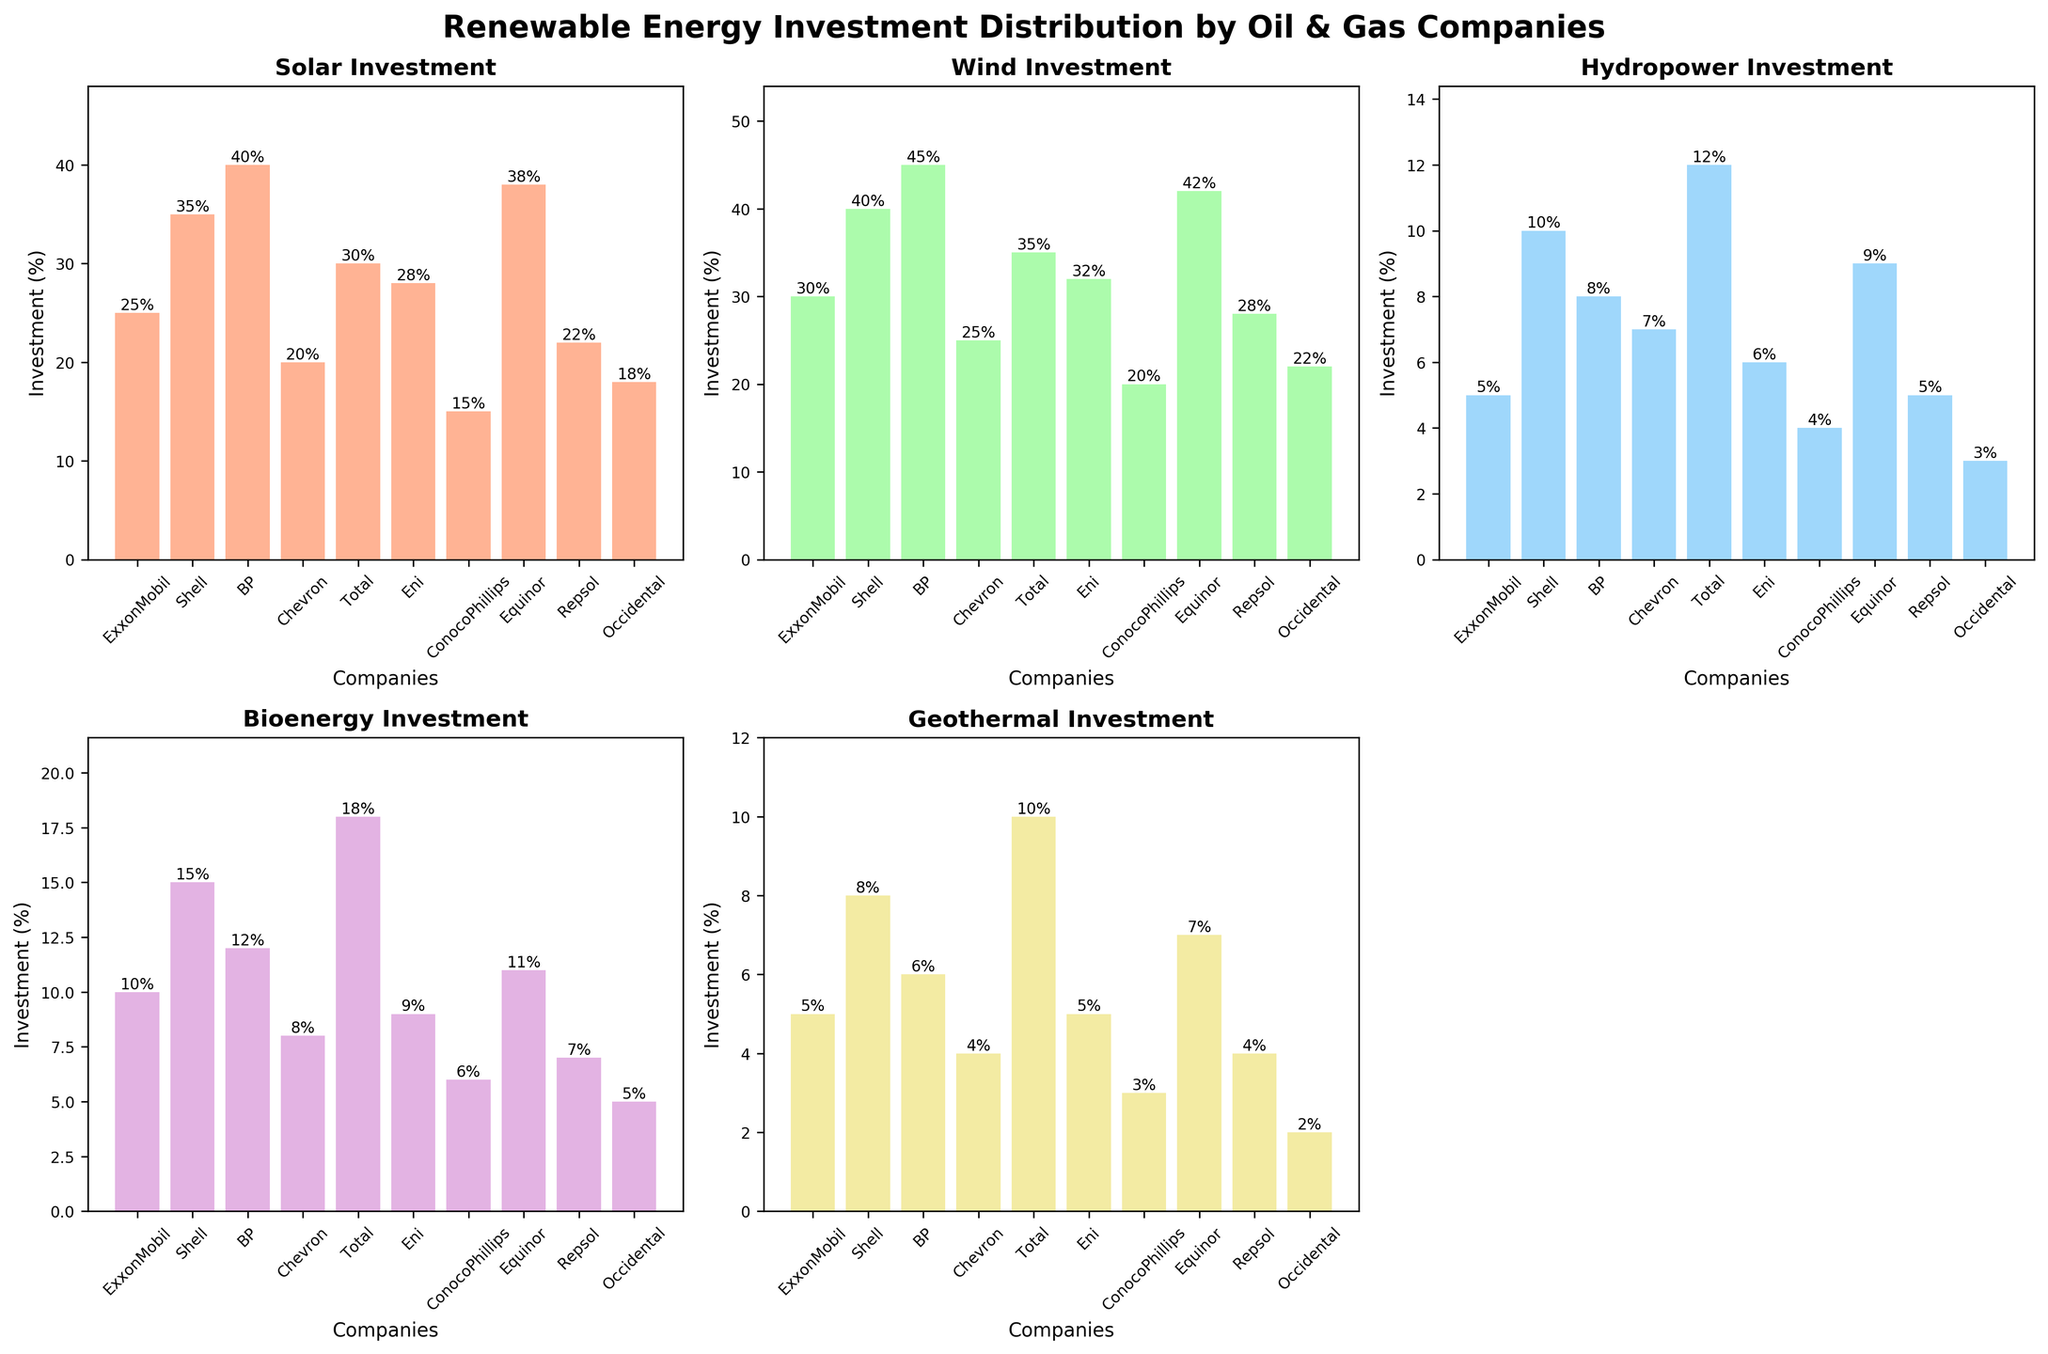What's the title of the figure? The title is displayed at the top center of the figure, it reads "Renewable Energy Investment Distribution by Oil & Gas Companies".
Answer: Renewable Energy Investment Distribution by Oil & Gas Companies How many subplots are there in the figure? The figure is composed of a grid of subplots, filling 5 subplots and removing the 6th one as it's not used, there are 5 subplots total.
Answer: 5 Which company has the highest investment in Solar energy? In the Solar energy subplot, BP has the tallest bar, indicating the highest investment percentage (40%).
Answer: BP What is the Bioenergy investment percentage for Eni? In the Bioenergy subplot, the bar above Eni is at 9%.
Answer: 9% Which company has the lowest investment in Geothermal energy? In the Geothermal energy subplot, Occidental has the shortest bar, indicating the lowest investment percentage (2%).
Answer: Occidental What is the average investment percentage in Wind energy? To find the average, sum the investment percentages of all companies in Wind energy (30+40+45+25+35+32+20+42+28+22) = 319, and then divide by the number of companies (10): 319/10 = 31.9%.
Answer: 31.9% How do the Solar and Wind energy investments for Equinor compare? In the respective subplots, Equinor's Solar energy investment is 38%, while its Wind energy investment is 42%. Comparing the two, Equinor invests 4% more in Wind energy.
Answer: 4% more in Wind What's the difference between the highest and lowest investments in Hydropower? The highest Hydropower investment is by Total (12%) and the lowest is by ConocoPhillips (4%). The difference is 12 - 4 = 8%.
Answer: 8% Which type of renewable energy has the most even distribution across the companies? By visually inspecting the subplots, noticing the relatively uniform heights of the bars, Bioenergy has a more even distribution across the companies compared to other types.
Answer: Bioenergy What's the combined investment percentage in Geothermal energy by BP and Chevron? BP's Geothermal investment is 6%, and Chevron's is 4%. The combined investment is 6 + 4 = 10%.
Answer: 10% 